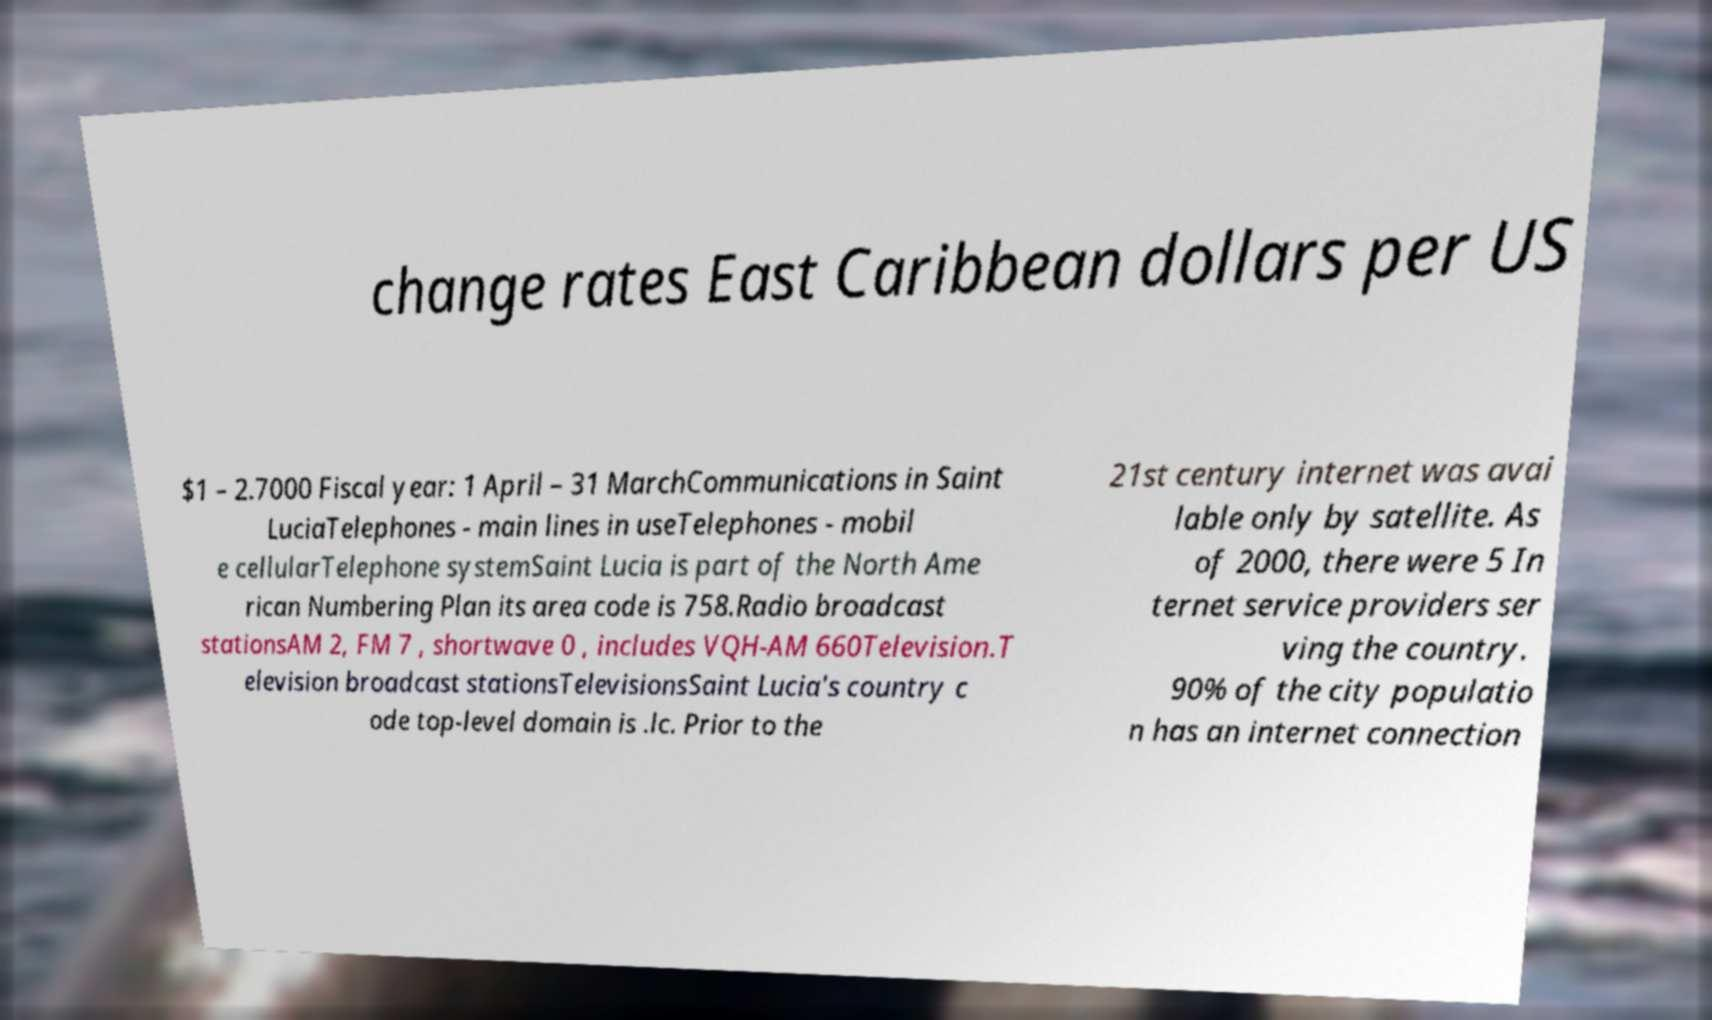Could you extract and type out the text from this image? change rates East Caribbean dollars per US $1 – 2.7000 Fiscal year: 1 April – 31 MarchCommunications in Saint LuciaTelephones - main lines in useTelephones - mobil e cellularTelephone systemSaint Lucia is part of the North Ame rican Numbering Plan its area code is 758.Radio broadcast stationsAM 2, FM 7 , shortwave 0 , includes VQH-AM 660Television.T elevision broadcast stationsTelevisionsSaint Lucia's country c ode top-level domain is .lc. Prior to the 21st century internet was avai lable only by satellite. As of 2000, there were 5 In ternet service providers ser ving the country. 90% of the city populatio n has an internet connection 